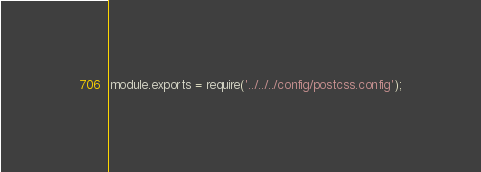<code> <loc_0><loc_0><loc_500><loc_500><_JavaScript_>module.exports = require('../../../config/postcss.config');
</code> 